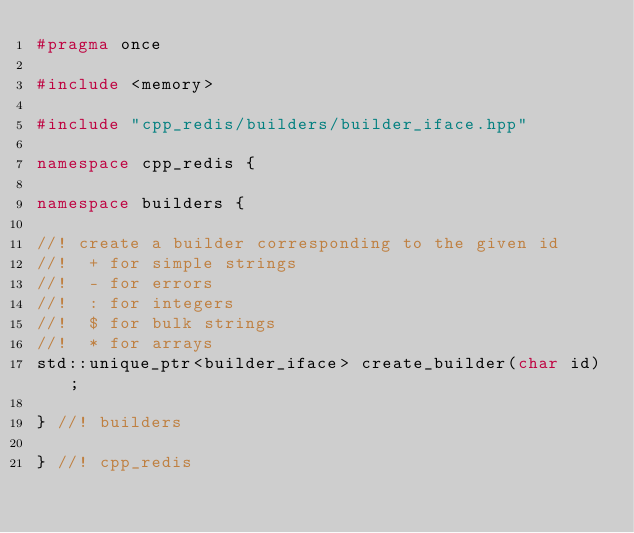Convert code to text. <code><loc_0><loc_0><loc_500><loc_500><_C++_>#pragma once

#include <memory>

#include "cpp_redis/builders/builder_iface.hpp"

namespace cpp_redis {

namespace builders {

//! create a builder corresponding to the given id
//!  + for simple strings
//!  - for errors
//!  : for integers
//!  $ for bulk strings
//!  * for arrays
std::unique_ptr<builder_iface> create_builder(char id);

} //! builders

} //! cpp_redis
</code> 